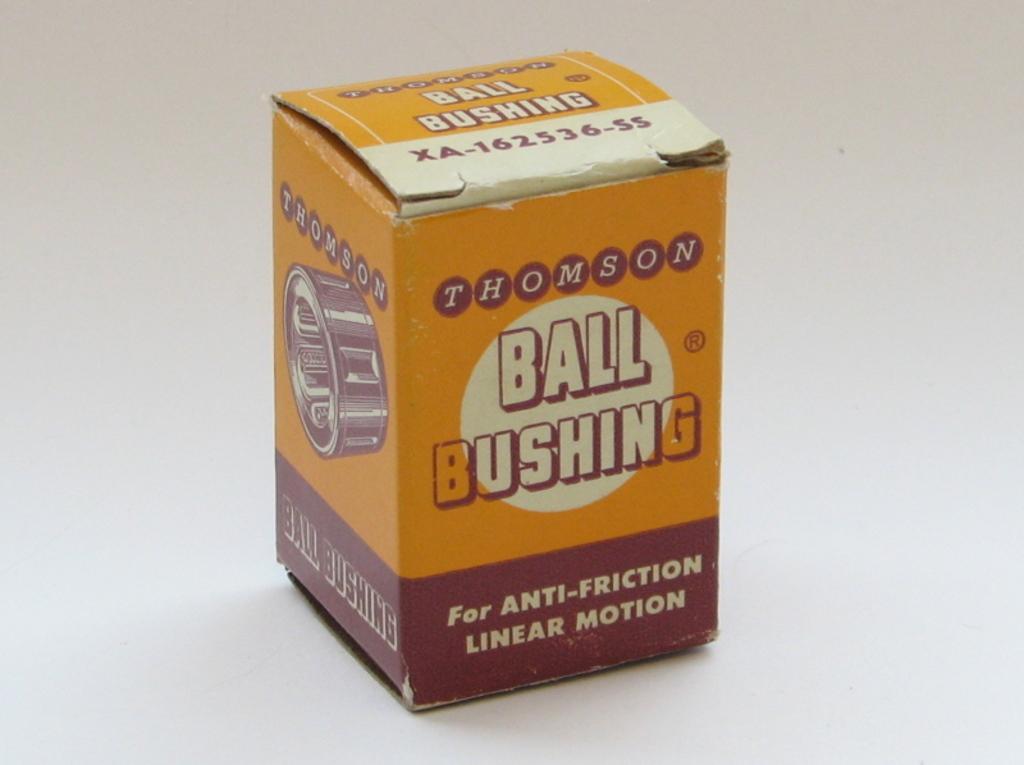Please provide a concise description of this image. In this image I can see a box is on the white surface. Something is written on the box. 